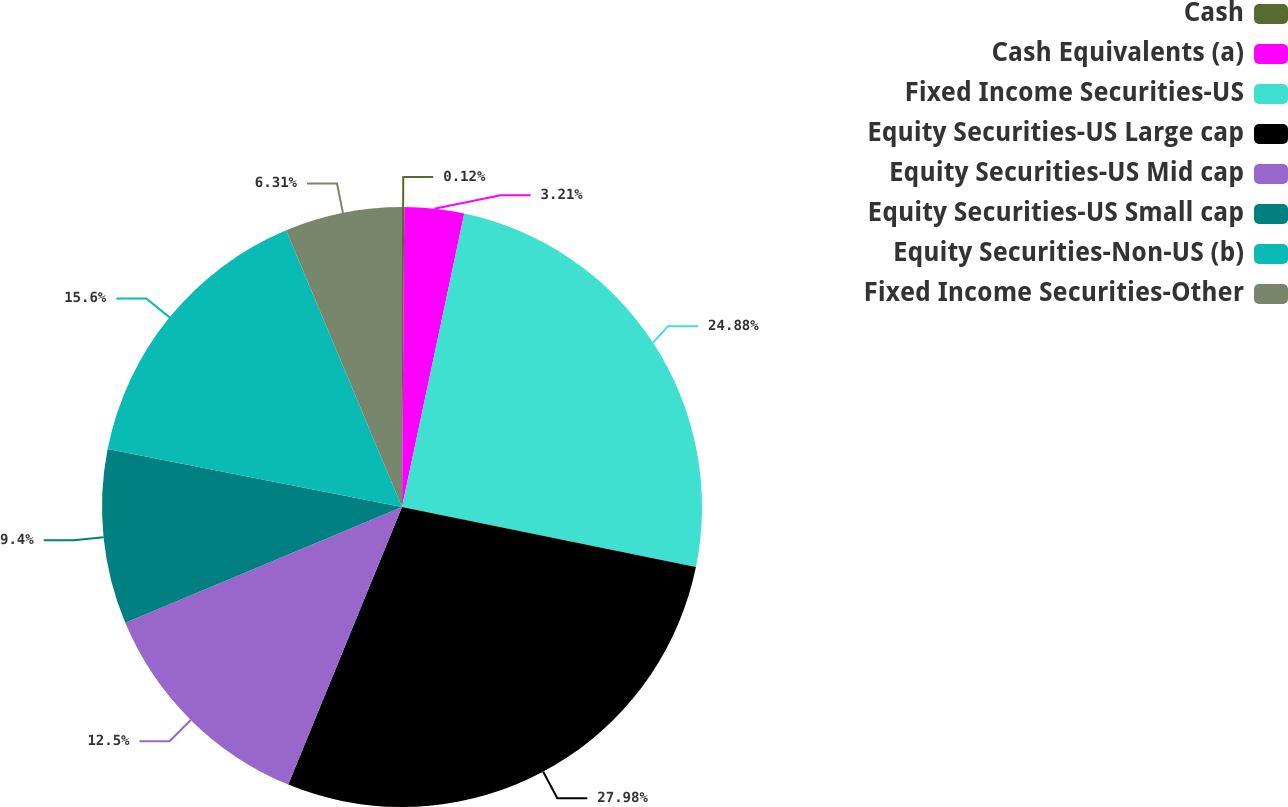<chart> <loc_0><loc_0><loc_500><loc_500><pie_chart><fcel>Cash<fcel>Cash Equivalents (a)<fcel>Fixed Income Securities-US<fcel>Equity Securities-US Large cap<fcel>Equity Securities-US Mid cap<fcel>Equity Securities-US Small cap<fcel>Equity Securities-Non-US (b)<fcel>Fixed Income Securities-Other<nl><fcel>0.12%<fcel>3.21%<fcel>24.88%<fcel>27.98%<fcel>12.5%<fcel>9.4%<fcel>15.6%<fcel>6.31%<nl></chart> 